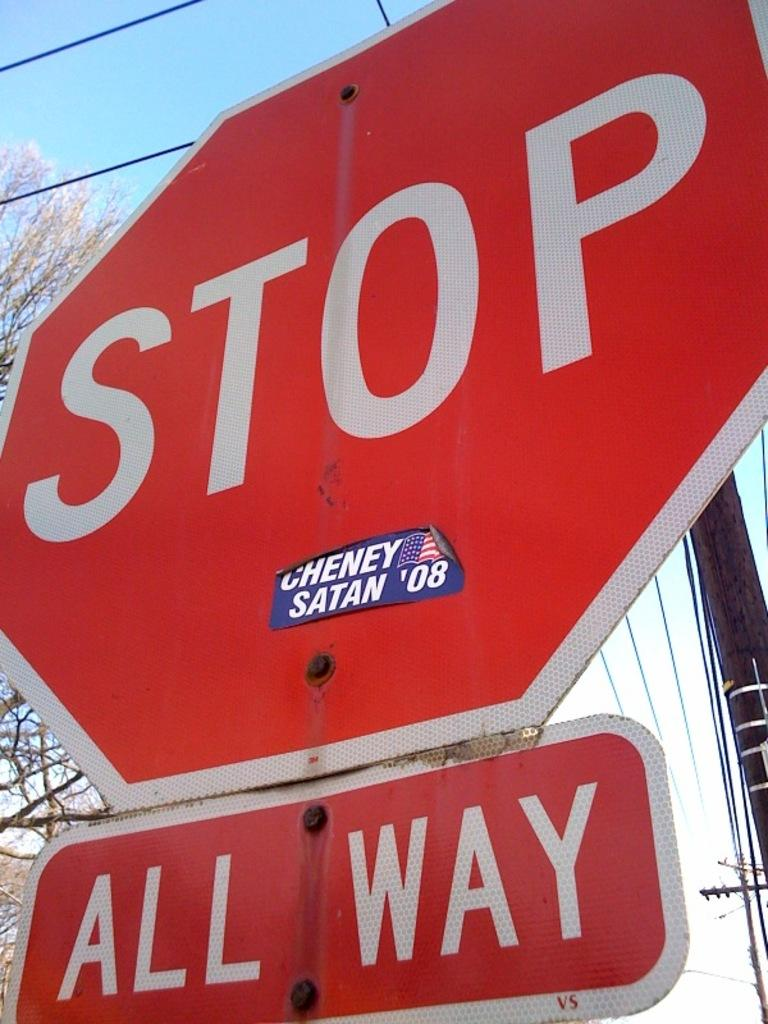Provide a one-sentence caption for the provided image. A red stop sign with another sign underneath reading 'All Way'. 